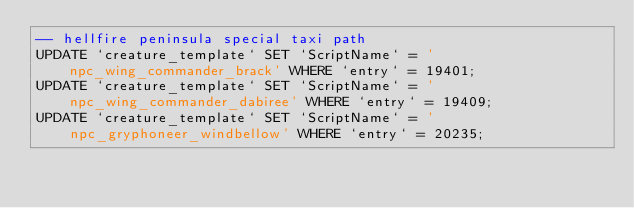<code> <loc_0><loc_0><loc_500><loc_500><_SQL_>-- hellfire peninsula special taxi path
UPDATE `creature_template` SET `ScriptName` = 'npc_wing_commander_brack' WHERE `entry` = 19401;
UPDATE `creature_template` SET `ScriptName` = 'npc_wing_commander_dabiree' WHERE `entry` = 19409;
UPDATE `creature_template` SET `ScriptName` = 'npc_gryphoneer_windbellow' WHERE `entry` = 20235;
</code> 